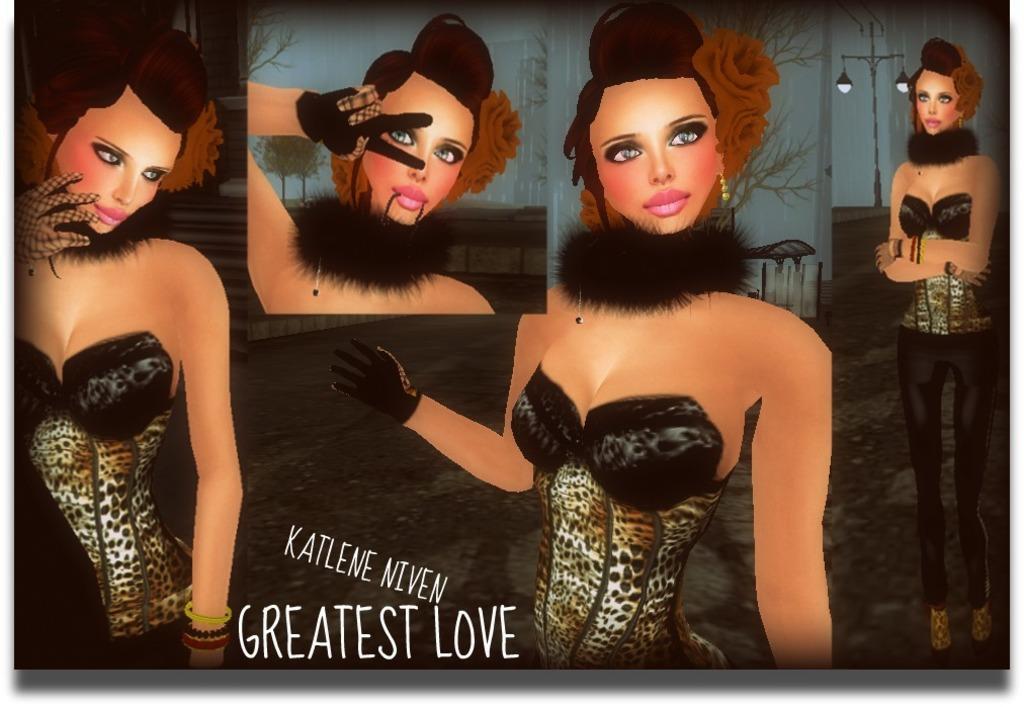Describe this image in one or two sentences. This is a drawing in this drawing there are different gestures of a lady, in this drawing it is written as the greatest love. 